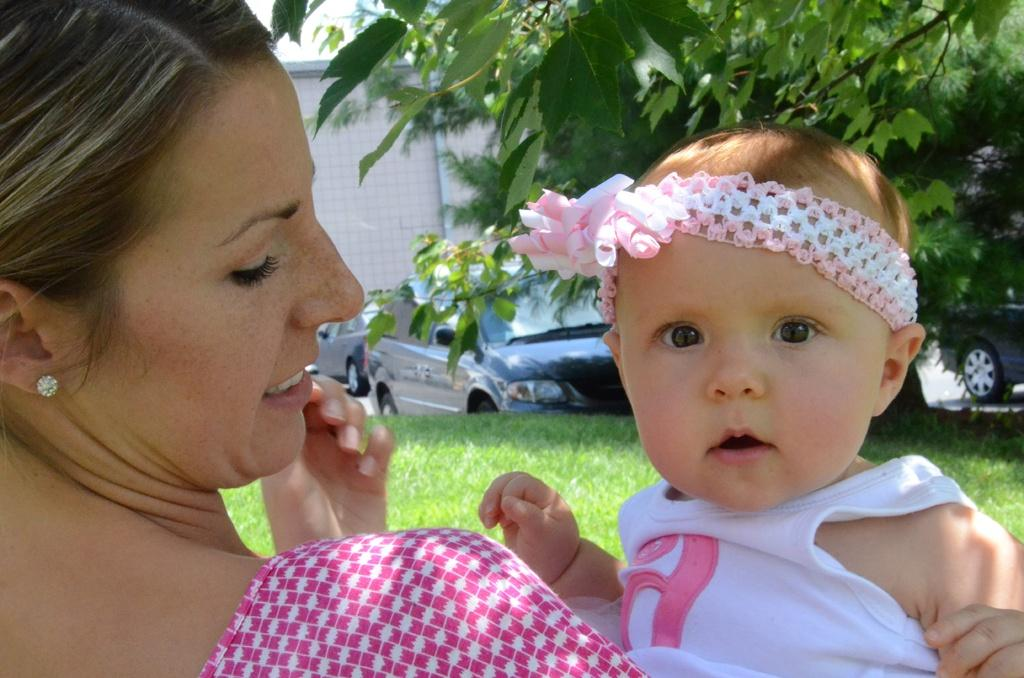Who is in the image? There is a woman in the image. What is the woman holding? The woman is holding a baby. What can be seen on the right side of the image? There are trees on the grassland on the right side of the image. What is present on the road in the image? Vehicles are present on the road. What is visible in the background of the image? There is a wall visible in the background of the image. What type of lunch is being prepared in the pail on the left side of the image? There is no pail or lunch present in the image. Can you describe the door in the image? There is no door present in the image. 